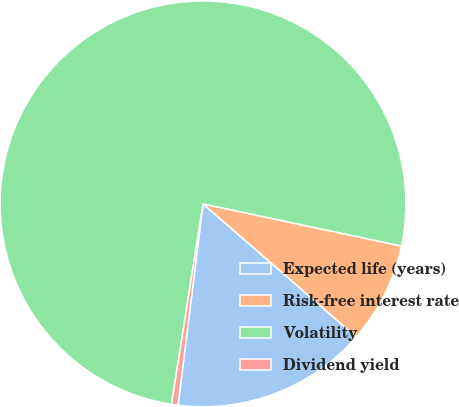Convert chart to OTSL. <chart><loc_0><loc_0><loc_500><loc_500><pie_chart><fcel>Expected life (years)<fcel>Risk-free interest rate<fcel>Volatility<fcel>Dividend yield<nl><fcel>15.58%<fcel>8.05%<fcel>75.85%<fcel>0.52%<nl></chart> 